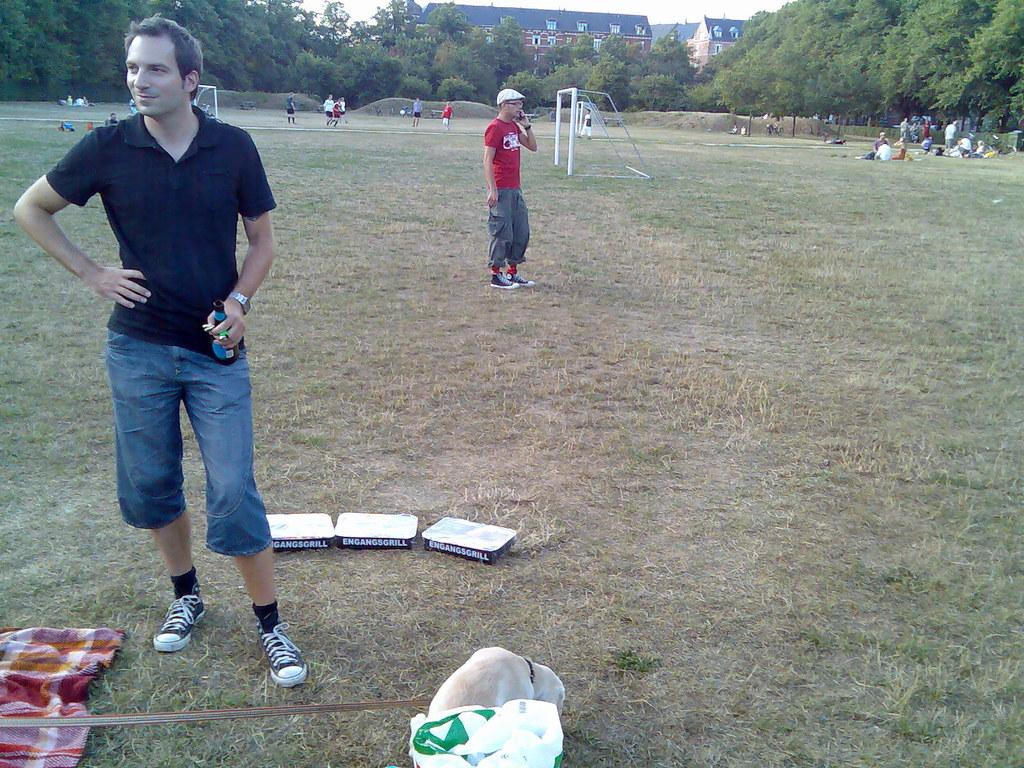What are the people in the image doing on the ground? People are playing on the ground in the image. What can be seen in the background of the image? Trees and buildings are visible in the background of the image. How many people are present in the image? The number of people is not specified, but there are people standing on the ground. What type of knowledge can be gained from the needle in the image? There is no needle present in the image, so no knowledge can be gained from it. 